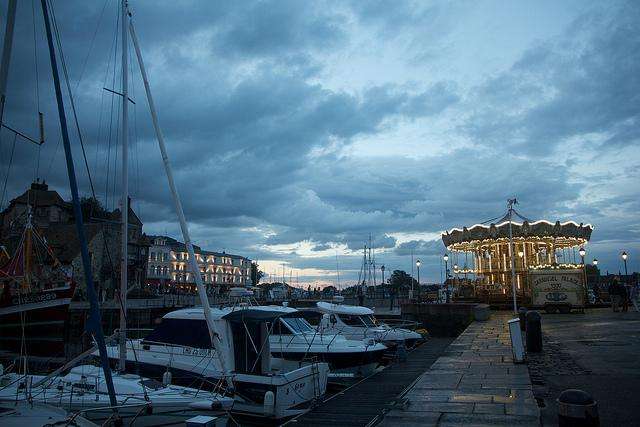What carved imagery animal is likely found on the amusement ride shown here? Please explain your reasoning. horse. The ride is a carousel. carousels are known to most commonly feature horses. 